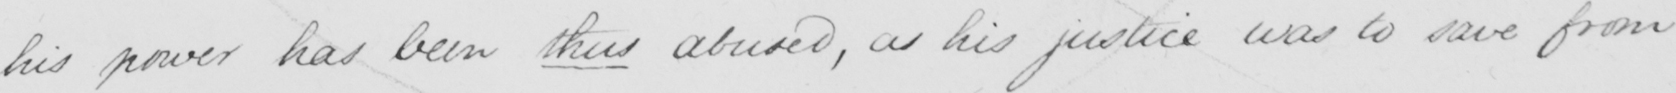What does this handwritten line say? his power has been thus abused , as his justice was to save from 